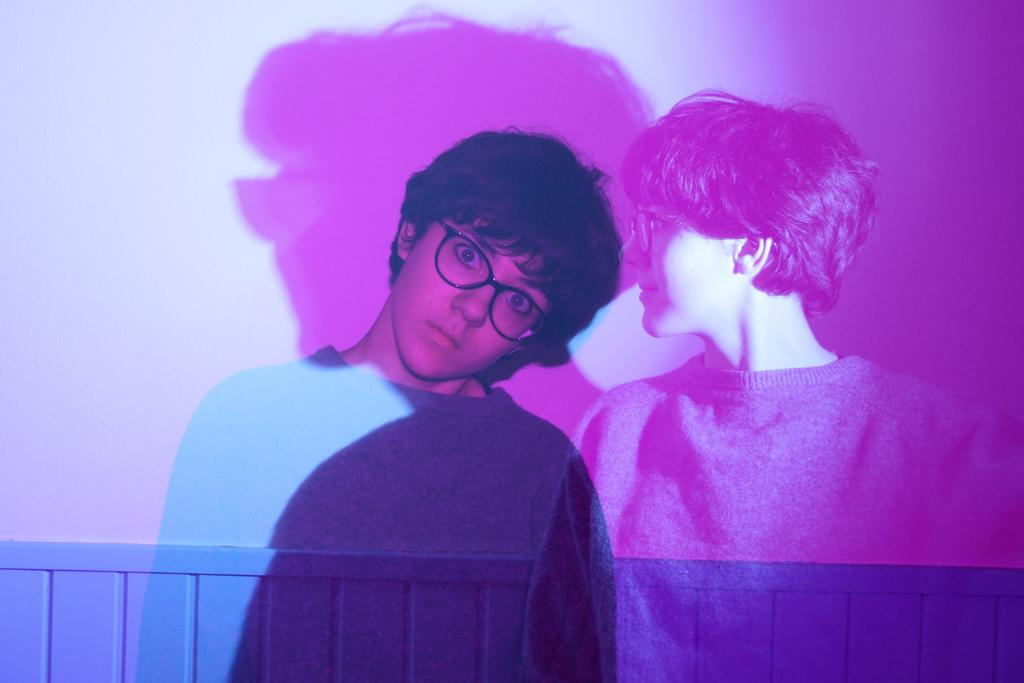What can be seen on the wall in the image? There are reflections of a person on the wall in the image. What colors are the boys wearing in the image? There are no boys present in the image; it only features reflections of a person on the wall. What achievements can be seen in the image? There are no achievements visible in the image; it only features reflections of a person on the wall. 